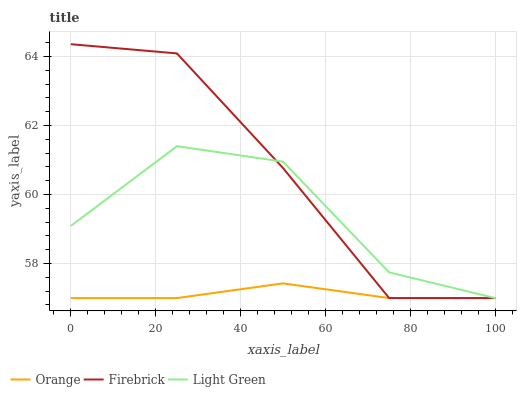Does Light Green have the minimum area under the curve?
Answer yes or no. No. Does Light Green have the maximum area under the curve?
Answer yes or no. No. Is Firebrick the smoothest?
Answer yes or no. No. Is Firebrick the roughest?
Answer yes or no. No. Does Light Green have the highest value?
Answer yes or no. No. 